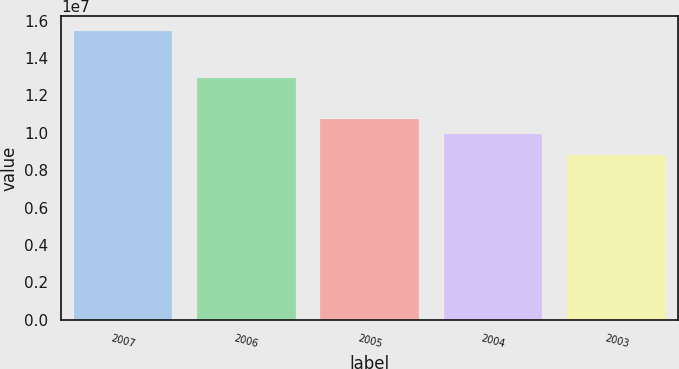Convert chart. <chart><loc_0><loc_0><loc_500><loc_500><bar_chart><fcel>2007<fcel>2006<fcel>2005<fcel>2004<fcel>2003<nl><fcel>1.5463e+07<fcel>1.2933e+07<fcel>1.075e+07<fcel>9.931e+06<fcel>8.798e+06<nl></chart> 